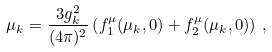Convert formula to latex. <formula><loc_0><loc_0><loc_500><loc_500>\mu _ { k } = \frac { 3 g _ { k } ^ { 2 } } { ( 4 \pi ) ^ { 2 } } \left ( f _ { 1 } ^ { \mu } ( \mu _ { k } , 0 ) + f _ { 2 } ^ { \mu } ( \mu _ { k } , 0 ) \right ) \, ,</formula> 